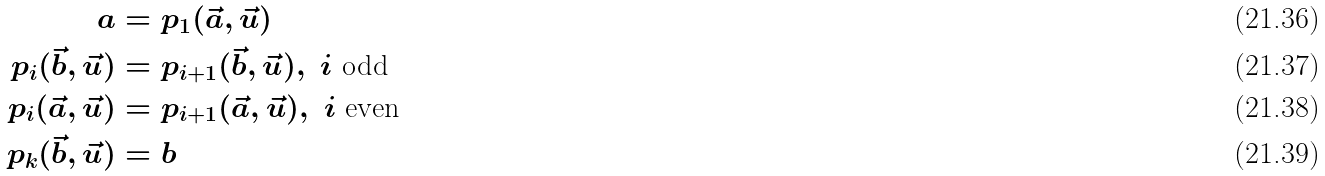Convert formula to latex. <formula><loc_0><loc_0><loc_500><loc_500>a & = p _ { 1 } ( \vec { a } , \vec { u } ) \\ p _ { i } ( \vec { b } , \vec { u } ) & = p _ { i + 1 } ( \vec { b } , \vec { u } ) , \ i \text { odd} \\ p _ { i } ( \vec { a } , \vec { u } ) & = p _ { i + 1 } ( \vec { a } , \vec { u } ) , \ i \text { even} \\ p _ { k } ( \vec { b } , \vec { u } ) & = b</formula> 